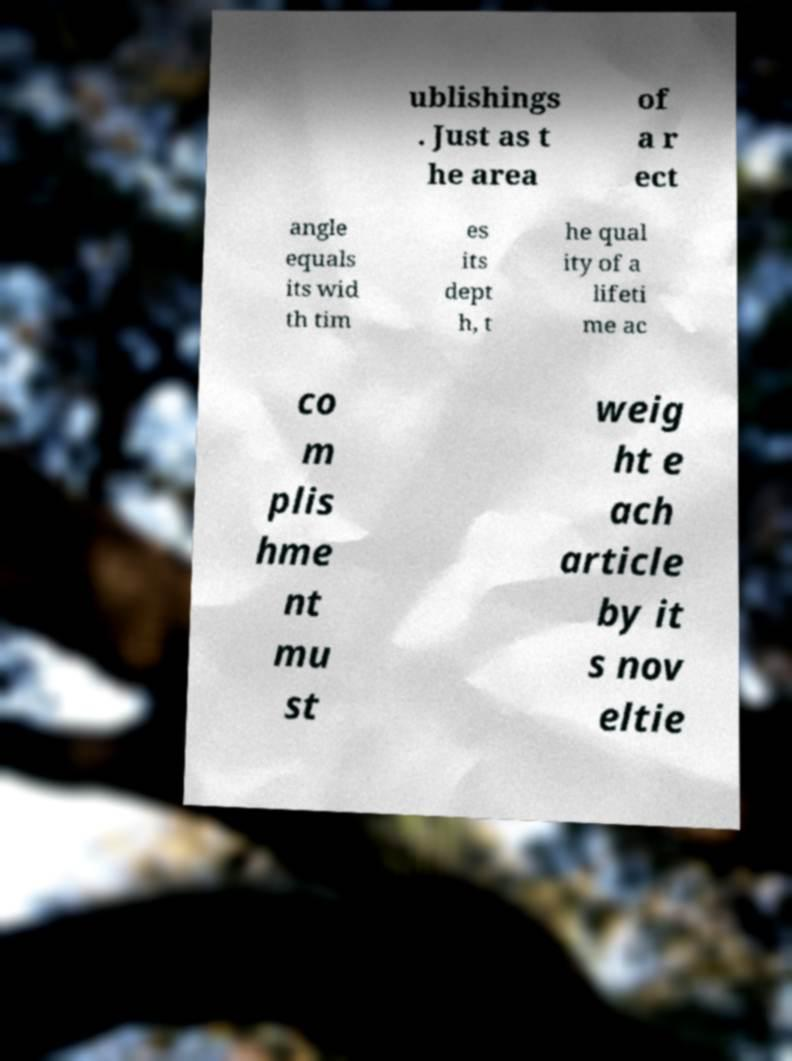What messages or text are displayed in this image? I need them in a readable, typed format. ublishings . Just as t he area of a r ect angle equals its wid th tim es its dept h, t he qual ity of a lifeti me ac co m plis hme nt mu st weig ht e ach article by it s nov eltie 